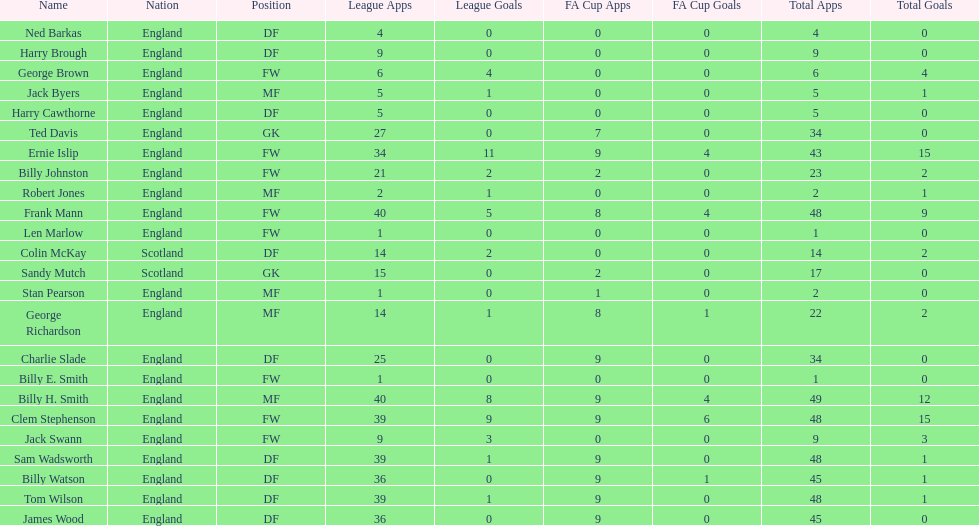What is the ultimate last name shown on this table? James Wood. 